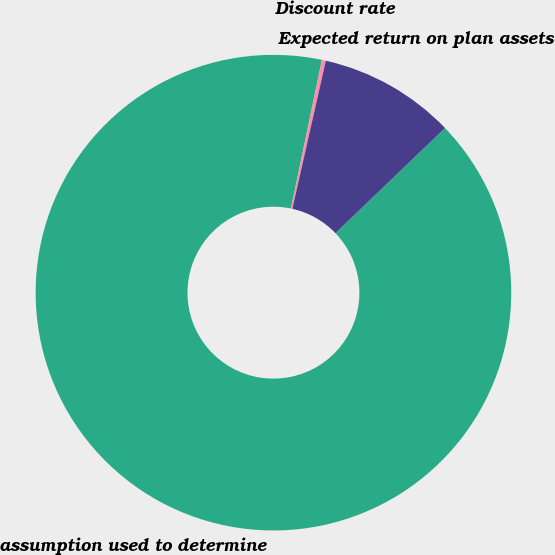Convert chart. <chart><loc_0><loc_0><loc_500><loc_500><pie_chart><fcel>assumption used to determine<fcel>Discount rate<fcel>Expected return on plan assets<nl><fcel>90.43%<fcel>0.27%<fcel>9.29%<nl></chart> 